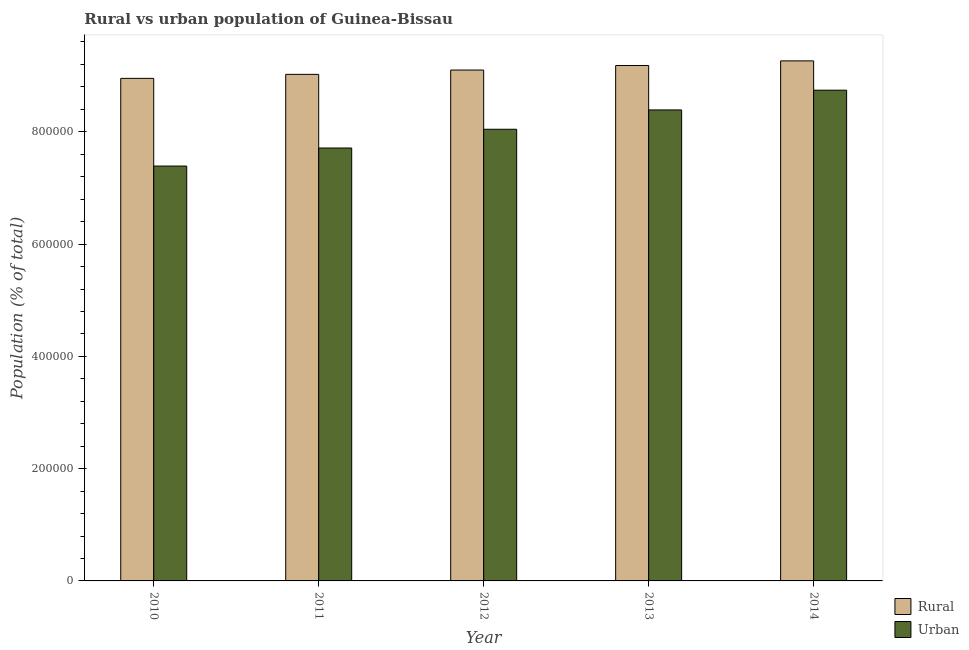How many groups of bars are there?
Offer a very short reply. 5. Are the number of bars per tick equal to the number of legend labels?
Keep it short and to the point. Yes. Are the number of bars on each tick of the X-axis equal?
Provide a short and direct response. Yes. What is the label of the 4th group of bars from the left?
Give a very brief answer. 2013. What is the urban population density in 2013?
Provide a short and direct response. 8.39e+05. Across all years, what is the maximum urban population density?
Give a very brief answer. 8.74e+05. Across all years, what is the minimum urban population density?
Make the answer very short. 7.39e+05. What is the total urban population density in the graph?
Your answer should be compact. 4.03e+06. What is the difference between the rural population density in 2011 and that in 2014?
Your answer should be compact. -2.40e+04. What is the difference between the urban population density in 2011 and the rural population density in 2014?
Offer a terse response. -1.03e+05. What is the average urban population density per year?
Your answer should be compact. 8.06e+05. In the year 2012, what is the difference between the rural population density and urban population density?
Offer a very short reply. 0. In how many years, is the rural population density greater than 120000 %?
Keep it short and to the point. 5. What is the ratio of the rural population density in 2010 to that in 2011?
Offer a terse response. 0.99. Is the urban population density in 2010 less than that in 2014?
Offer a very short reply. Yes. Is the difference between the urban population density in 2010 and 2014 greater than the difference between the rural population density in 2010 and 2014?
Your answer should be compact. No. What is the difference between the highest and the second highest urban population density?
Provide a short and direct response. 3.52e+04. What is the difference between the highest and the lowest rural population density?
Offer a terse response. 3.12e+04. In how many years, is the rural population density greater than the average rural population density taken over all years?
Your response must be concise. 2. What does the 1st bar from the left in 2010 represents?
Offer a very short reply. Rural. What does the 2nd bar from the right in 2012 represents?
Provide a short and direct response. Rural. Are all the bars in the graph horizontal?
Make the answer very short. No. Are the values on the major ticks of Y-axis written in scientific E-notation?
Offer a terse response. No. Where does the legend appear in the graph?
Your response must be concise. Bottom right. How many legend labels are there?
Ensure brevity in your answer.  2. How are the legend labels stacked?
Ensure brevity in your answer.  Vertical. What is the title of the graph?
Keep it short and to the point. Rural vs urban population of Guinea-Bissau. What is the label or title of the X-axis?
Provide a short and direct response. Year. What is the label or title of the Y-axis?
Your response must be concise. Population (% of total). What is the Population (% of total) of Rural in 2010?
Offer a terse response. 8.95e+05. What is the Population (% of total) in Urban in 2010?
Your answer should be compact. 7.39e+05. What is the Population (% of total) in Rural in 2011?
Your response must be concise. 9.02e+05. What is the Population (% of total) in Urban in 2011?
Give a very brief answer. 7.71e+05. What is the Population (% of total) of Rural in 2012?
Make the answer very short. 9.10e+05. What is the Population (% of total) of Urban in 2012?
Make the answer very short. 8.05e+05. What is the Population (% of total) of Rural in 2013?
Make the answer very short. 9.18e+05. What is the Population (% of total) of Urban in 2013?
Your answer should be compact. 8.39e+05. What is the Population (% of total) in Rural in 2014?
Your response must be concise. 9.26e+05. What is the Population (% of total) in Urban in 2014?
Ensure brevity in your answer.  8.74e+05. Across all years, what is the maximum Population (% of total) of Rural?
Offer a terse response. 9.26e+05. Across all years, what is the maximum Population (% of total) in Urban?
Offer a very short reply. 8.74e+05. Across all years, what is the minimum Population (% of total) of Rural?
Your answer should be very brief. 8.95e+05. Across all years, what is the minimum Population (% of total) in Urban?
Give a very brief answer. 7.39e+05. What is the total Population (% of total) in Rural in the graph?
Your answer should be compact. 4.55e+06. What is the total Population (% of total) of Urban in the graph?
Offer a terse response. 4.03e+06. What is the difference between the Population (% of total) of Rural in 2010 and that in 2011?
Ensure brevity in your answer.  -7143. What is the difference between the Population (% of total) of Urban in 2010 and that in 2011?
Your response must be concise. -3.22e+04. What is the difference between the Population (% of total) in Rural in 2010 and that in 2012?
Offer a very short reply. -1.49e+04. What is the difference between the Population (% of total) in Urban in 2010 and that in 2012?
Keep it short and to the point. -6.56e+04. What is the difference between the Population (% of total) of Rural in 2010 and that in 2013?
Keep it short and to the point. -2.30e+04. What is the difference between the Population (% of total) in Urban in 2010 and that in 2013?
Ensure brevity in your answer.  -1.00e+05. What is the difference between the Population (% of total) of Rural in 2010 and that in 2014?
Your answer should be very brief. -3.12e+04. What is the difference between the Population (% of total) of Urban in 2010 and that in 2014?
Your answer should be compact. -1.35e+05. What is the difference between the Population (% of total) of Rural in 2011 and that in 2012?
Offer a terse response. -7713. What is the difference between the Population (% of total) of Urban in 2011 and that in 2012?
Your response must be concise. -3.34e+04. What is the difference between the Population (% of total) of Rural in 2011 and that in 2013?
Give a very brief answer. -1.58e+04. What is the difference between the Population (% of total) of Urban in 2011 and that in 2013?
Your response must be concise. -6.78e+04. What is the difference between the Population (% of total) in Rural in 2011 and that in 2014?
Offer a terse response. -2.40e+04. What is the difference between the Population (% of total) of Urban in 2011 and that in 2014?
Provide a short and direct response. -1.03e+05. What is the difference between the Population (% of total) in Rural in 2012 and that in 2013?
Make the answer very short. -8105. What is the difference between the Population (% of total) in Urban in 2012 and that in 2013?
Ensure brevity in your answer.  -3.44e+04. What is the difference between the Population (% of total) in Rural in 2012 and that in 2014?
Provide a short and direct response. -1.63e+04. What is the difference between the Population (% of total) of Urban in 2012 and that in 2014?
Offer a terse response. -6.96e+04. What is the difference between the Population (% of total) of Rural in 2013 and that in 2014?
Keep it short and to the point. -8207. What is the difference between the Population (% of total) in Urban in 2013 and that in 2014?
Ensure brevity in your answer.  -3.52e+04. What is the difference between the Population (% of total) of Rural in 2010 and the Population (% of total) of Urban in 2011?
Keep it short and to the point. 1.24e+05. What is the difference between the Population (% of total) of Rural in 2010 and the Population (% of total) of Urban in 2012?
Your answer should be very brief. 9.06e+04. What is the difference between the Population (% of total) of Rural in 2010 and the Population (% of total) of Urban in 2013?
Provide a succinct answer. 5.62e+04. What is the difference between the Population (% of total) of Rural in 2010 and the Population (% of total) of Urban in 2014?
Provide a short and direct response. 2.10e+04. What is the difference between the Population (% of total) of Rural in 2011 and the Population (% of total) of Urban in 2012?
Keep it short and to the point. 9.78e+04. What is the difference between the Population (% of total) of Rural in 2011 and the Population (% of total) of Urban in 2013?
Provide a succinct answer. 6.34e+04. What is the difference between the Population (% of total) in Rural in 2011 and the Population (% of total) in Urban in 2014?
Provide a succinct answer. 2.82e+04. What is the difference between the Population (% of total) in Rural in 2012 and the Population (% of total) in Urban in 2013?
Your answer should be compact. 7.11e+04. What is the difference between the Population (% of total) in Rural in 2012 and the Population (% of total) in Urban in 2014?
Make the answer very short. 3.59e+04. What is the difference between the Population (% of total) of Rural in 2013 and the Population (% of total) of Urban in 2014?
Keep it short and to the point. 4.40e+04. What is the average Population (% of total) of Rural per year?
Offer a very short reply. 9.10e+05. What is the average Population (% of total) of Urban per year?
Offer a very short reply. 8.06e+05. In the year 2010, what is the difference between the Population (% of total) of Rural and Population (% of total) of Urban?
Keep it short and to the point. 1.56e+05. In the year 2011, what is the difference between the Population (% of total) of Rural and Population (% of total) of Urban?
Provide a succinct answer. 1.31e+05. In the year 2012, what is the difference between the Population (% of total) of Rural and Population (% of total) of Urban?
Offer a terse response. 1.05e+05. In the year 2013, what is the difference between the Population (% of total) of Rural and Population (% of total) of Urban?
Give a very brief answer. 7.92e+04. In the year 2014, what is the difference between the Population (% of total) in Rural and Population (% of total) in Urban?
Keep it short and to the point. 5.22e+04. What is the ratio of the Population (% of total) of Rural in 2010 to that in 2012?
Your response must be concise. 0.98. What is the ratio of the Population (% of total) in Urban in 2010 to that in 2012?
Give a very brief answer. 0.92. What is the ratio of the Population (% of total) in Urban in 2010 to that in 2013?
Keep it short and to the point. 0.88. What is the ratio of the Population (% of total) of Rural in 2010 to that in 2014?
Ensure brevity in your answer.  0.97. What is the ratio of the Population (% of total) of Urban in 2010 to that in 2014?
Provide a succinct answer. 0.85. What is the ratio of the Population (% of total) of Urban in 2011 to that in 2012?
Offer a very short reply. 0.96. What is the ratio of the Population (% of total) of Rural in 2011 to that in 2013?
Ensure brevity in your answer.  0.98. What is the ratio of the Population (% of total) in Urban in 2011 to that in 2013?
Your answer should be very brief. 0.92. What is the ratio of the Population (% of total) in Rural in 2011 to that in 2014?
Keep it short and to the point. 0.97. What is the ratio of the Population (% of total) of Urban in 2011 to that in 2014?
Your answer should be compact. 0.88. What is the ratio of the Population (% of total) in Rural in 2012 to that in 2013?
Give a very brief answer. 0.99. What is the ratio of the Population (% of total) of Rural in 2012 to that in 2014?
Provide a succinct answer. 0.98. What is the ratio of the Population (% of total) in Urban in 2012 to that in 2014?
Provide a succinct answer. 0.92. What is the ratio of the Population (% of total) of Urban in 2013 to that in 2014?
Your answer should be very brief. 0.96. What is the difference between the highest and the second highest Population (% of total) of Rural?
Provide a succinct answer. 8207. What is the difference between the highest and the second highest Population (% of total) in Urban?
Give a very brief answer. 3.52e+04. What is the difference between the highest and the lowest Population (% of total) in Rural?
Your answer should be very brief. 3.12e+04. What is the difference between the highest and the lowest Population (% of total) in Urban?
Your answer should be very brief. 1.35e+05. 